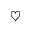<formula> <loc_0><loc_0><loc_500><loc_500>\heartsuit</formula> 